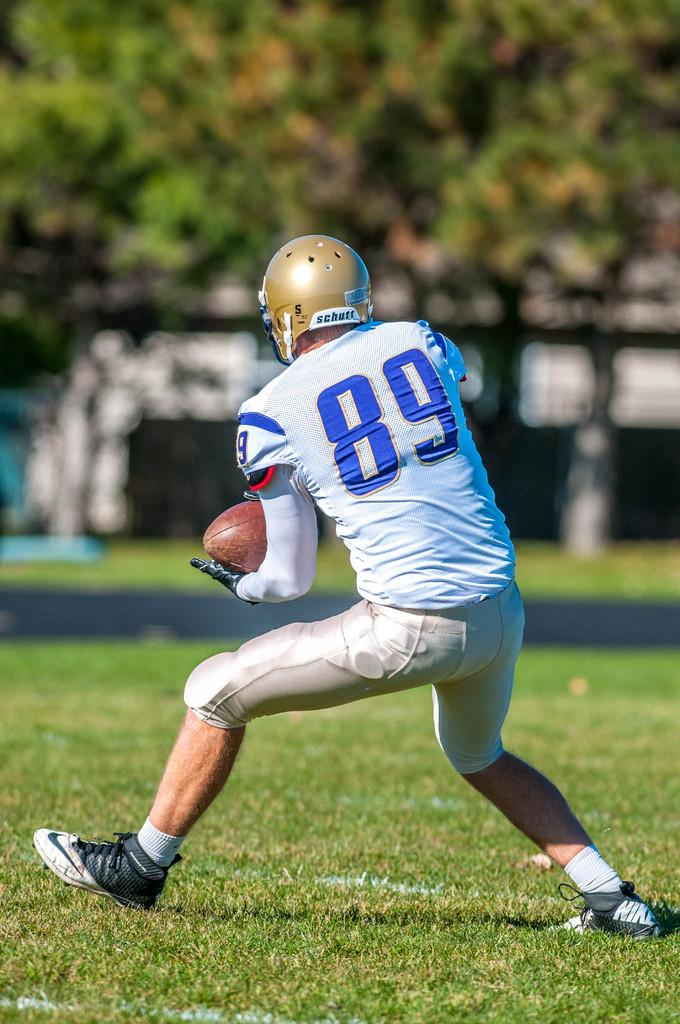What is the man in the image wearing on his head? The man is wearing a helmet. What other protective gear is the man wearing? The man is wearing gloves and shoes. What is the man holding in his hand? The man is holding a ball in his hand. What type of surface is the man standing on? The man is standing on grass. What can be seen in the background of the image? There are trees and a pillar in the background of the image. How would you describe the appearance of the background? The background appears blurry. What type of statement is the man making in the image? There is no indication in the image that the man is making a statement. What time is displayed on the clock in the image? There is no clock present in the image. Is there a net visible in the image? No, there is no net present in the image. 